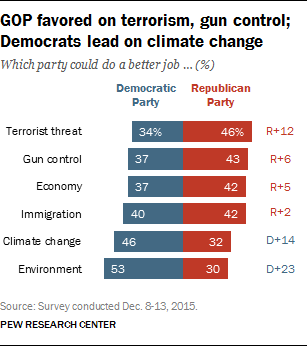List a handful of essential elements in this visual. The ratio (A:B) of occurrences of bars with values 37 and 42 is 0.042361111... The value of the first red bar from the bottom is 30. 